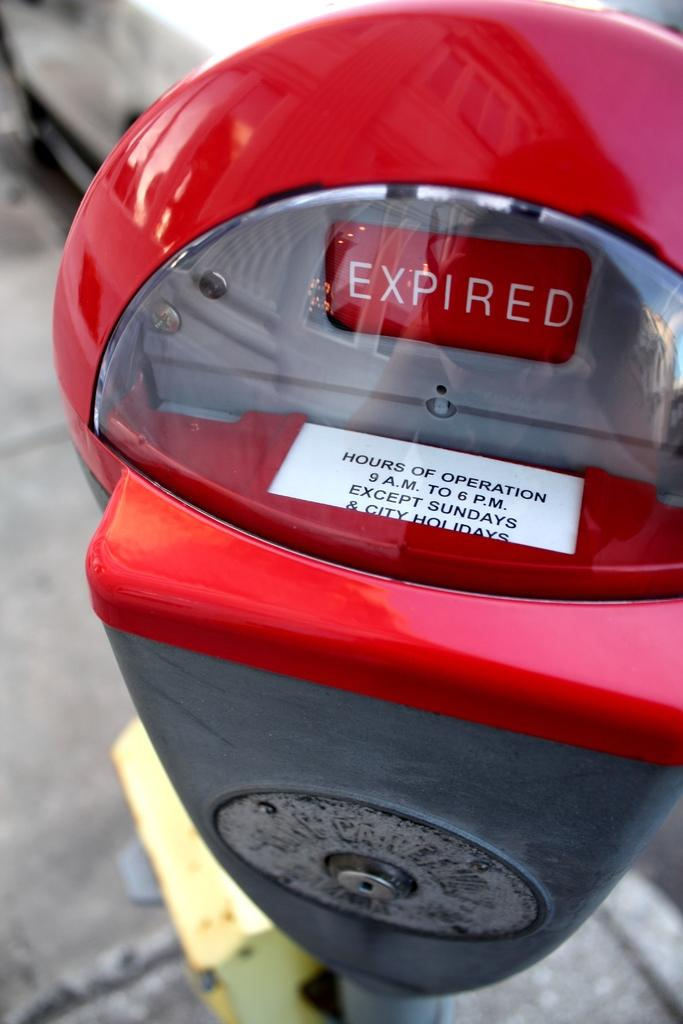<image>
Share a concise interpretation of the image provided. A red and black parking meter that says expired in a large white font. 